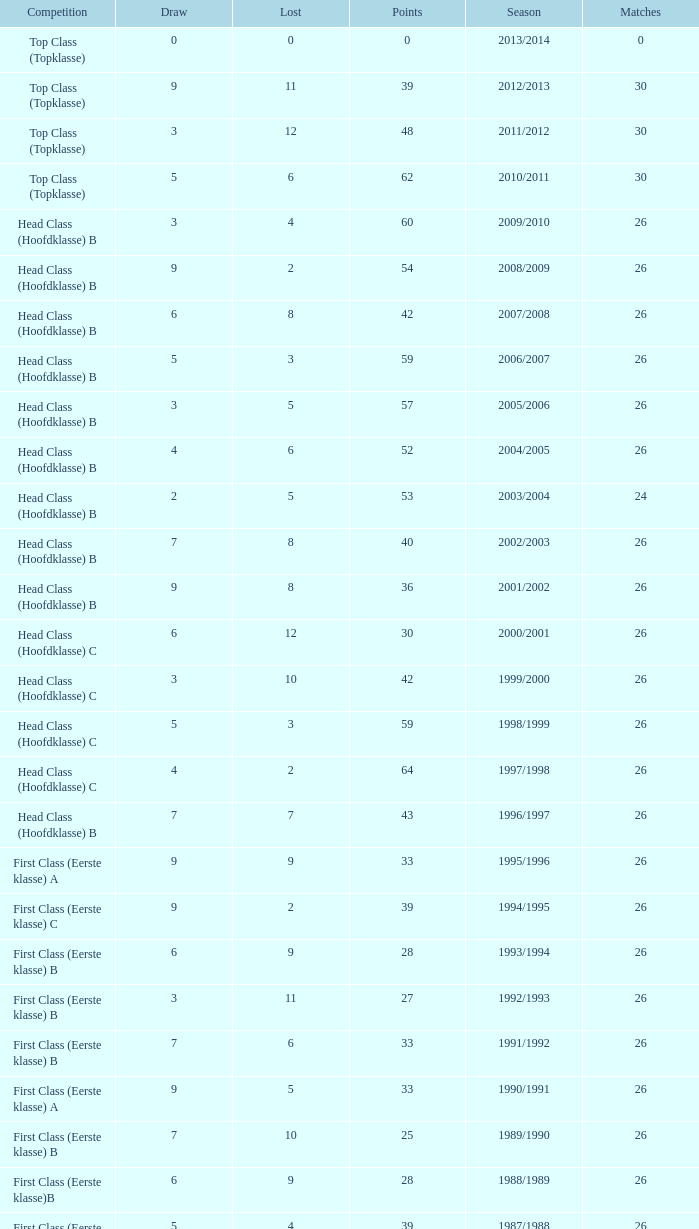What is the total number of matches with a loss less than 5 in the 2008/2009 season and has a draw larger than 9? 0.0. 